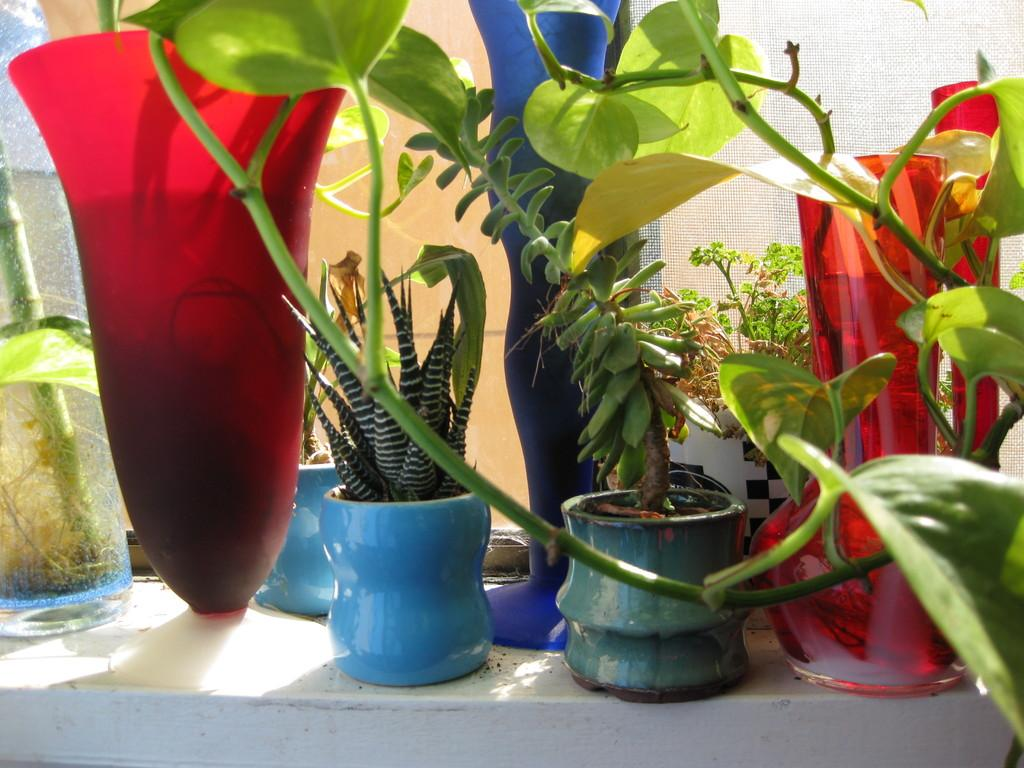What type of objects are present in the image? There are plant pots in the image. What is the color of the surface on which the plant pots are placed? The plant pots are on a white surface. What can be seen in the background of the image? There is a net visible in the background of the image, along with other objects. What is the condition of the school system in the image? There is no school system present in the image; it features plant pots on a white surface with a net visible in the background. 